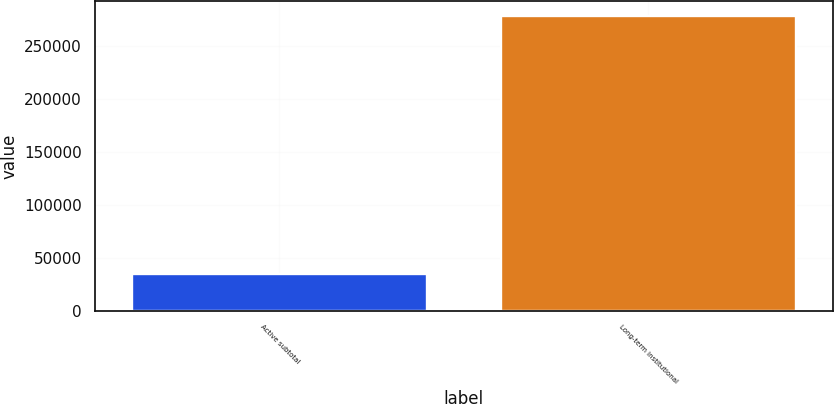Convert chart. <chart><loc_0><loc_0><loc_500><loc_500><bar_chart><fcel>Active subtotal<fcel>Long-term institutional<nl><fcel>34472<fcel>278336<nl></chart> 